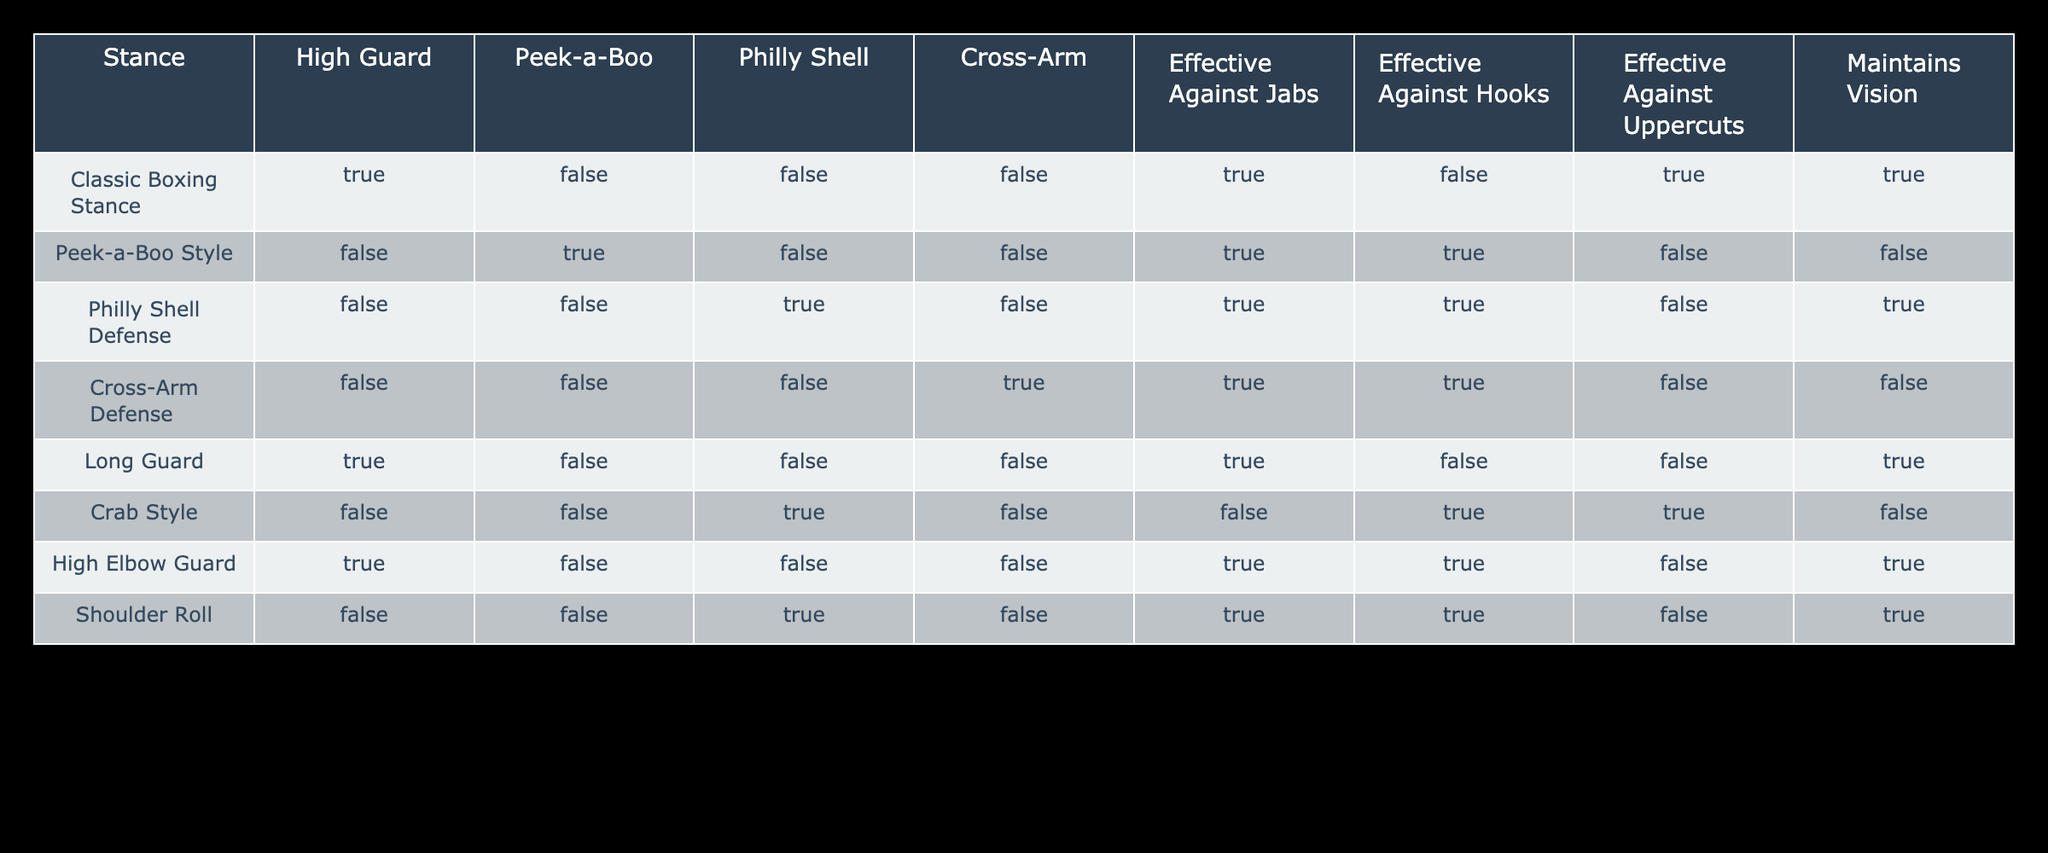What stance is most effective against jabs? From the table, the "Classic Boxing Stance," "Peek-a-Boo Style," "Philly Shell Defense," "Long Guard," "High Elbow Guard," and "Cross-Arm Defense" are all marked as effective against jabs (TRUE). However, the "Classic Boxing Stance" is the only stance that is effective against jabs while also maintaining vision.
Answer: Classic Boxing Stance Which stance is effective against uppercuts? Referring to the table, we see that "Classic Boxing Stance," "Long Guard," "Crab Style," and "Shoulder Roll" are marked as effective against uppercuts (TRUE). Therefore, there are four stances that can effectively counter uppercuts.
Answer: Four stances Does the Peek-a-Boo Style maintain vision? According to the table, the Peek-a-Boo Style is marked as FALSE for maintaining vision. This indicates that this stance may hinder the fighter's ability to see incoming punches well.
Answer: No Which stances are effective against hooks? The "Peek-a-Boo Style," "Cross-Arm Defense," and "Crab Style" are all shown to be effective against hooks (TRUE). This means that these three stances have strategies to defend against hook punches.
Answer: Three stances Is the Cross-Arm Defense effective against all types of punches? By closely examining the table, we can see that "Cross-Arm Defense" is marked as FALSE for effectiveness against jabs and uppercuts, while it is TRUE against hooks. Therefore, this stance is not effective against all types of punches, confirming that it has limitations.
Answer: No Which stance is the only one effective against both hooks and uppercuts? Looking at the data, the "Cross-Arm Defense" is effective against hooks (TRUE) but not uppercuts (FALSE). Conversely, the "Peek-a-Boo Style" is effective against hooks (TRUE) but not uppercuts (FALSE). The "Philly Shell Defense" is effective against both hooks (TRUE) but not uppercuts (FALSE). None of the stances are effective against both hooks and uppercuts.
Answer: None What percentage of stances are effective against jabs? There are a total of eight stances in the table, and five of them are effective against jabs (TRUE). To find the percentage, divide the number of effective stances (5) by the total stances (8) and multiply by 100, which results in (5/8)*100 = 62.5%.
Answer: 62.5% 